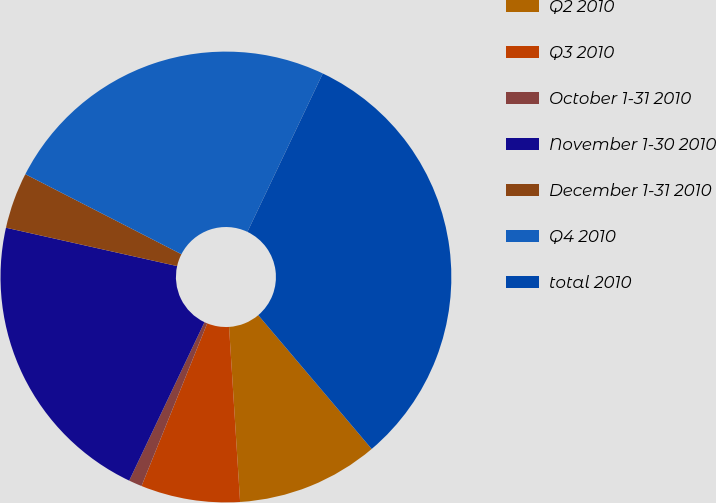<chart> <loc_0><loc_0><loc_500><loc_500><pie_chart><fcel>Q2 2010<fcel>Q3 2010<fcel>October 1-31 2010<fcel>November 1-30 2010<fcel>December 1-31 2010<fcel>Q4 2010<fcel>total 2010<nl><fcel>10.19%<fcel>7.11%<fcel>0.95%<fcel>21.45%<fcel>4.03%<fcel>24.53%<fcel>31.74%<nl></chart> 